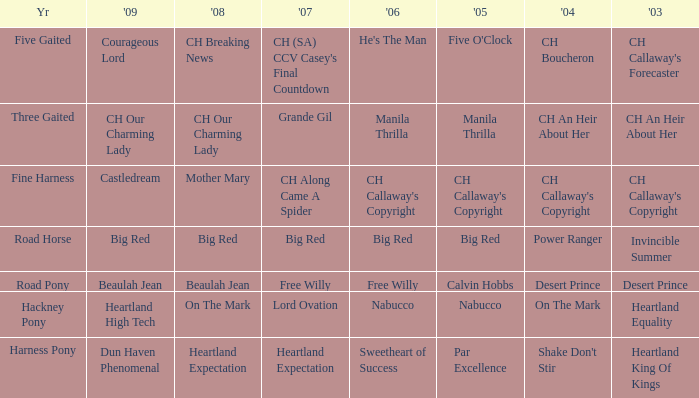What is the 2007 for the 2003 desert prince? Free Willy. 